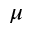<formula> <loc_0><loc_0><loc_500><loc_500>\mu</formula> 